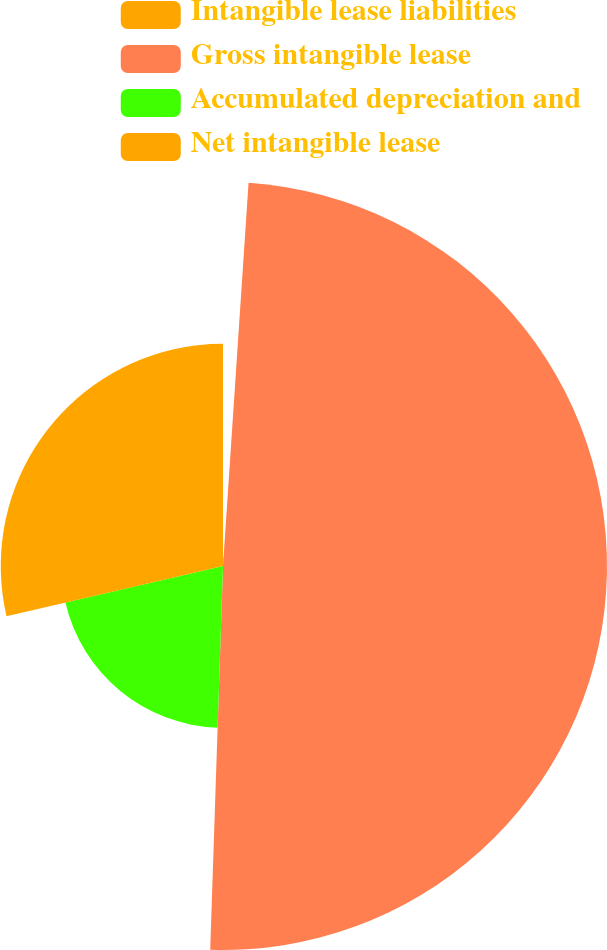Convert chart to OTSL. <chart><loc_0><loc_0><loc_500><loc_500><pie_chart><fcel>Intangible lease liabilities<fcel>Gross intangible lease<fcel>Accumulated depreciation and<fcel>Net intangible lease<nl><fcel>1.06%<fcel>49.47%<fcel>20.84%<fcel>28.63%<nl></chart> 